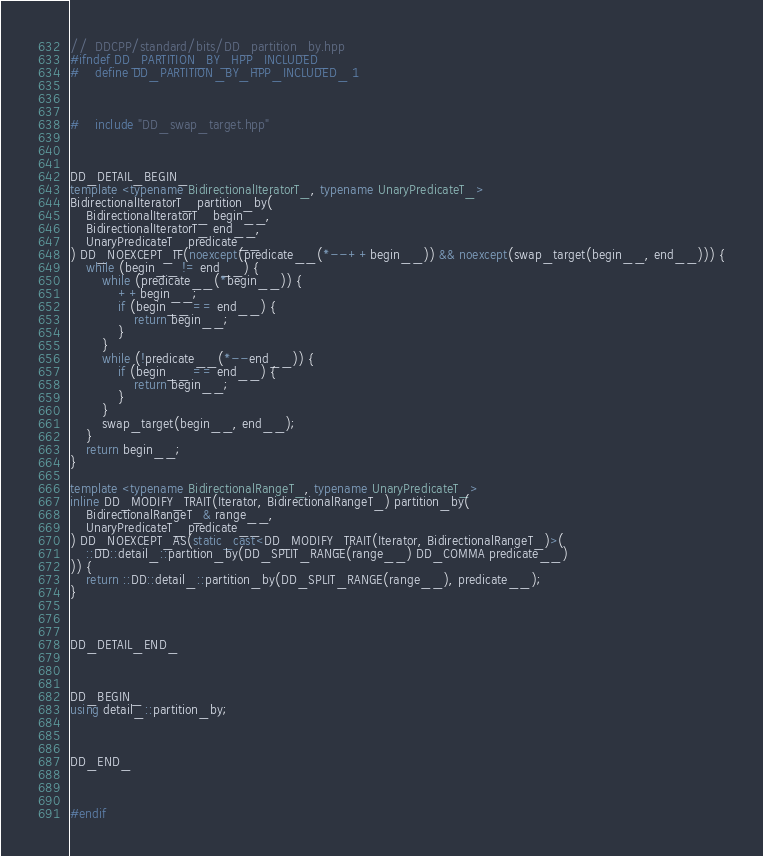<code> <loc_0><loc_0><loc_500><loc_500><_C++_>//	DDCPP/standard/bits/DD_partition_by.hpp
#ifndef DD_PARTITION_BY_HPP_INCLUDED_
#	define DD_PARTITION_BY_HPP_INCLUDED_ 1



#	include "DD_swap_target.hpp"



DD_DETAIL_BEGIN_
template <typename BidirectionalIteratorT_, typename UnaryPredicateT_>
BidirectionalIteratorT_ partition_by(
	BidirectionalIteratorT_ begin__,
	BidirectionalIteratorT_ end__,
	UnaryPredicateT_ predicate__
) DD_NOEXCEPT_IF(noexcept(predicate__(*--++begin__)) && noexcept(swap_target(begin__, end__))) {
	while (begin__ != end__) {
		while (predicate__(*begin__)) {
			++begin__;
			if (begin__ == end__) {
				return begin__;
			}
		}
		while (!predicate__(*--end__)) {
			if (begin__ == end__) {
				return begin__;
			}
		}
		swap_target(begin__, end__);
	}
	return begin__;
}

template <typename BidirectionalRangeT_, typename UnaryPredicateT_>
inline DD_MODIFY_TRAIT(Iterator, BidirectionalRangeT_) partition_by(
	BidirectionalRangeT_& range__,
	UnaryPredicateT_ predicate__
) DD_NOEXCEPT_AS(static_cast<DD_MODIFY_TRAIT(Iterator, BidirectionalRangeT_)>(
	::DD::detail_::partition_by(DD_SPLIT_RANGE(range__) DD_COMMA predicate__)
)) {
	return ::DD::detail_::partition_by(DD_SPLIT_RANGE(range__), predicate__);
}



DD_DETAIL_END_



DD_BEGIN_
using detail_::partition_by;



DD_END_



#endif
</code> 